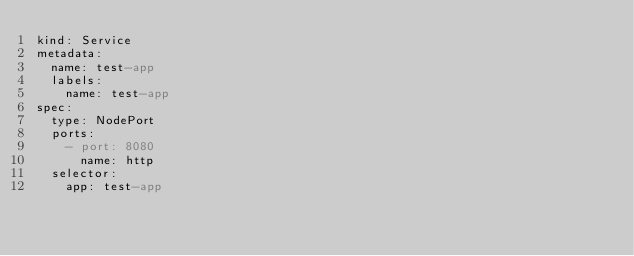<code> <loc_0><loc_0><loc_500><loc_500><_YAML_>kind: Service
metadata:
  name: test-app
  labels:
    name: test-app
spec:
  type: NodePort
  ports:
    - port: 8080
      name: http
  selector:
    app: test-app</code> 